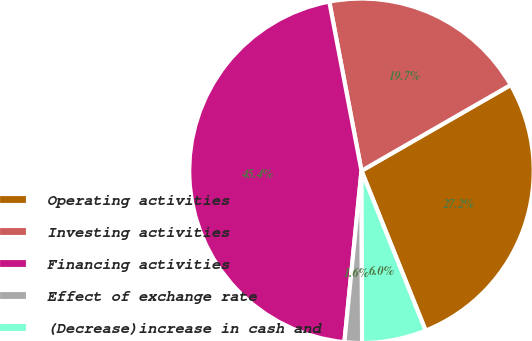Convert chart. <chart><loc_0><loc_0><loc_500><loc_500><pie_chart><fcel>Operating activities<fcel>Investing activities<fcel>Financing activities<fcel>Effect of exchange rate<fcel>(Decrease)increase in cash and<nl><fcel>27.23%<fcel>19.69%<fcel>45.42%<fcel>1.64%<fcel>6.02%<nl></chart> 